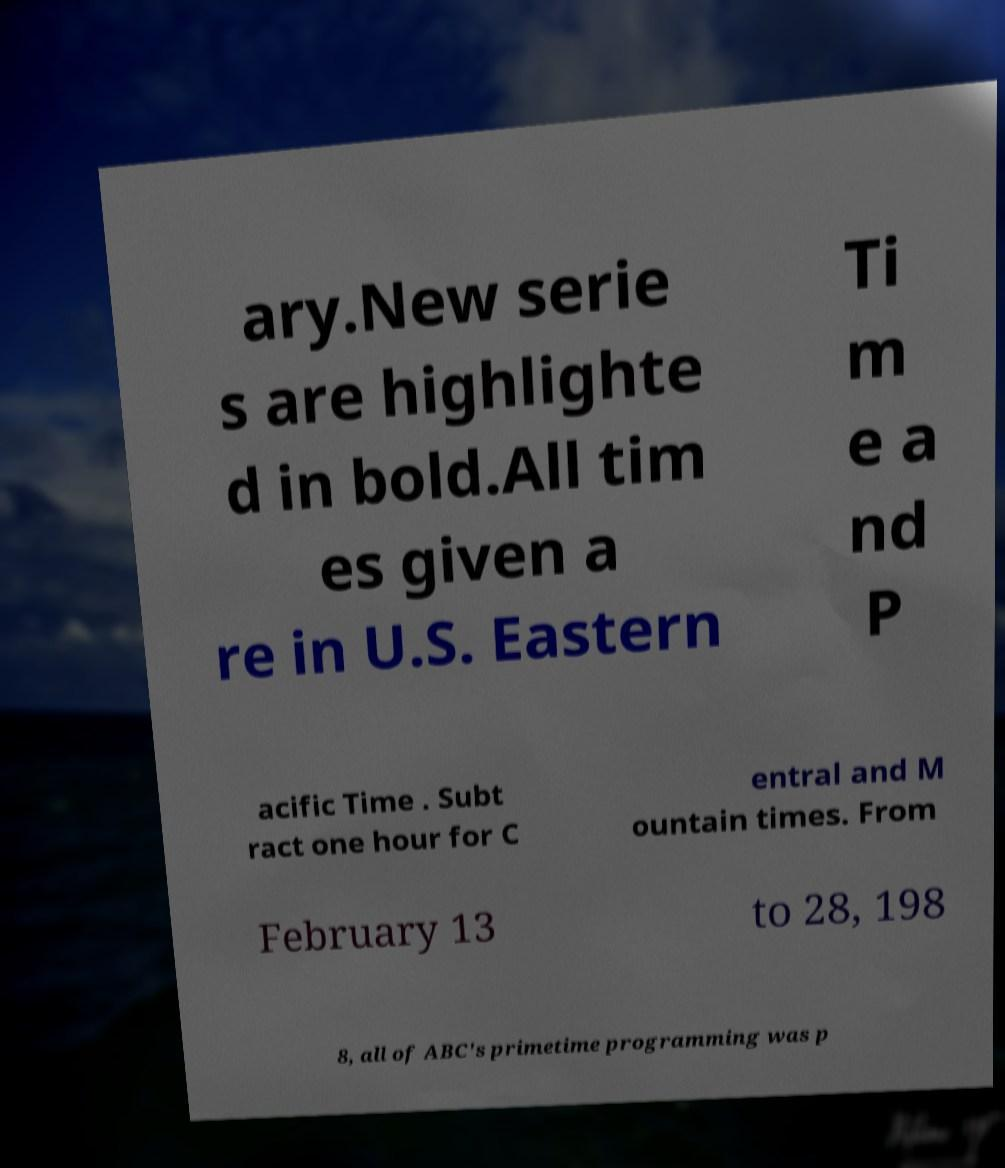Please identify and transcribe the text found in this image. ary.New serie s are highlighte d in bold.All tim es given a re in U.S. Eastern Ti m e a nd P acific Time . Subt ract one hour for C entral and M ountain times. From February 13 to 28, 198 8, all of ABC's primetime programming was p 